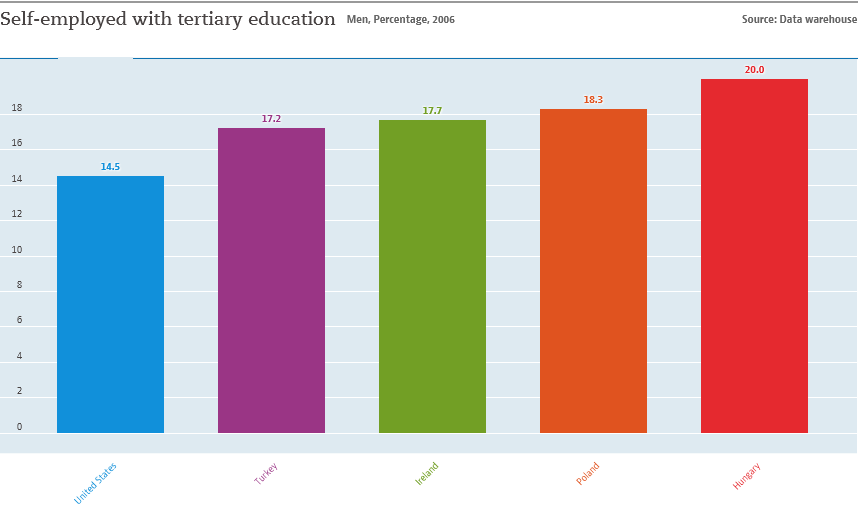Outline some significant characteristics in this image. According to the graph, Hungary has the highest percentage of self-employed individuals with tertiary education. The median of all bars is 17.7. 